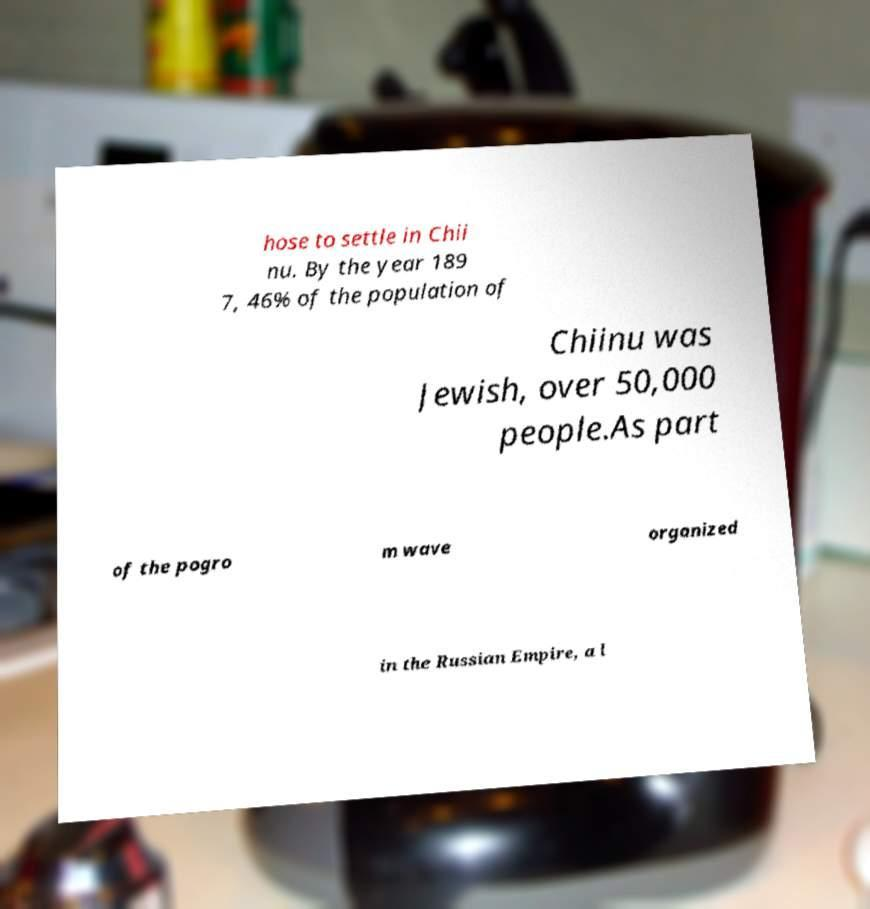Can you accurately transcribe the text from the provided image for me? hose to settle in Chii nu. By the year 189 7, 46% of the population of Chiinu was Jewish, over 50,000 people.As part of the pogro m wave organized in the Russian Empire, a l 